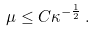<formula> <loc_0><loc_0><loc_500><loc_500>\mu \leq C \kappa ^ { - \frac { 1 } { 2 } } \, .</formula> 